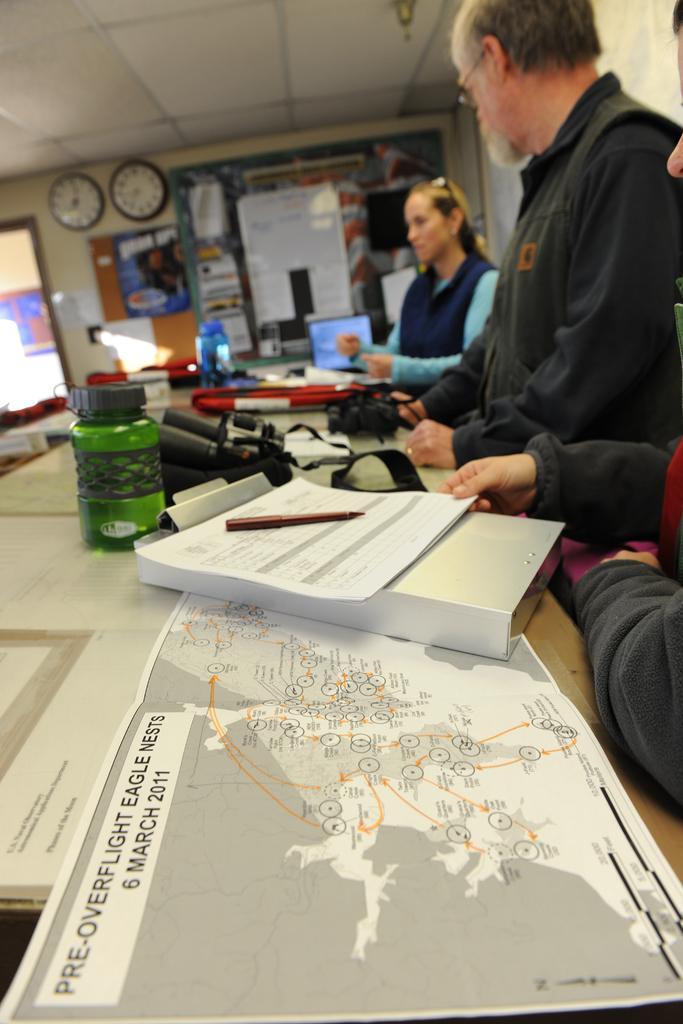Can you describe this image briefly? In this image there are three persons on the right side. In the center on the table there is a map chart, book, pen, bottle. In the background there are two clocks on the wall, building outside the door, and wall. 